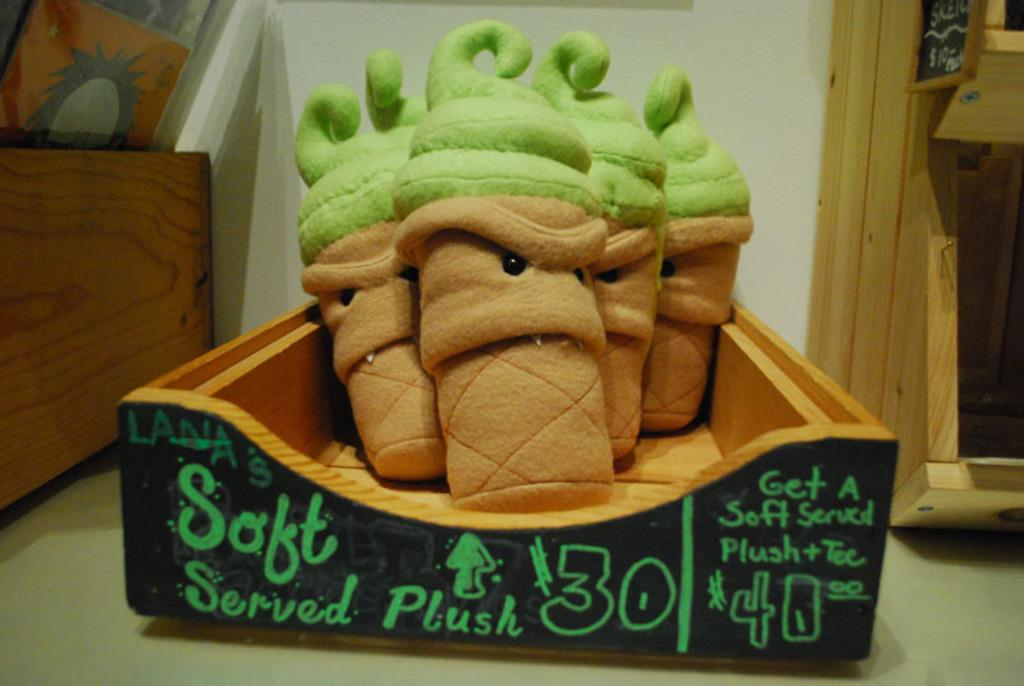What objects are inside the box in the image? There are toys in a box in the image. Where is the box located? The box is on a platform in the image. What can be seen in the background of the image? There is a wall, wooden objects, and a poster in the background of the image. What type of oil is being used to lubricate the calendar in the image? There is no calendar present in the image, and therefore no oil is being used to lubricate it. 